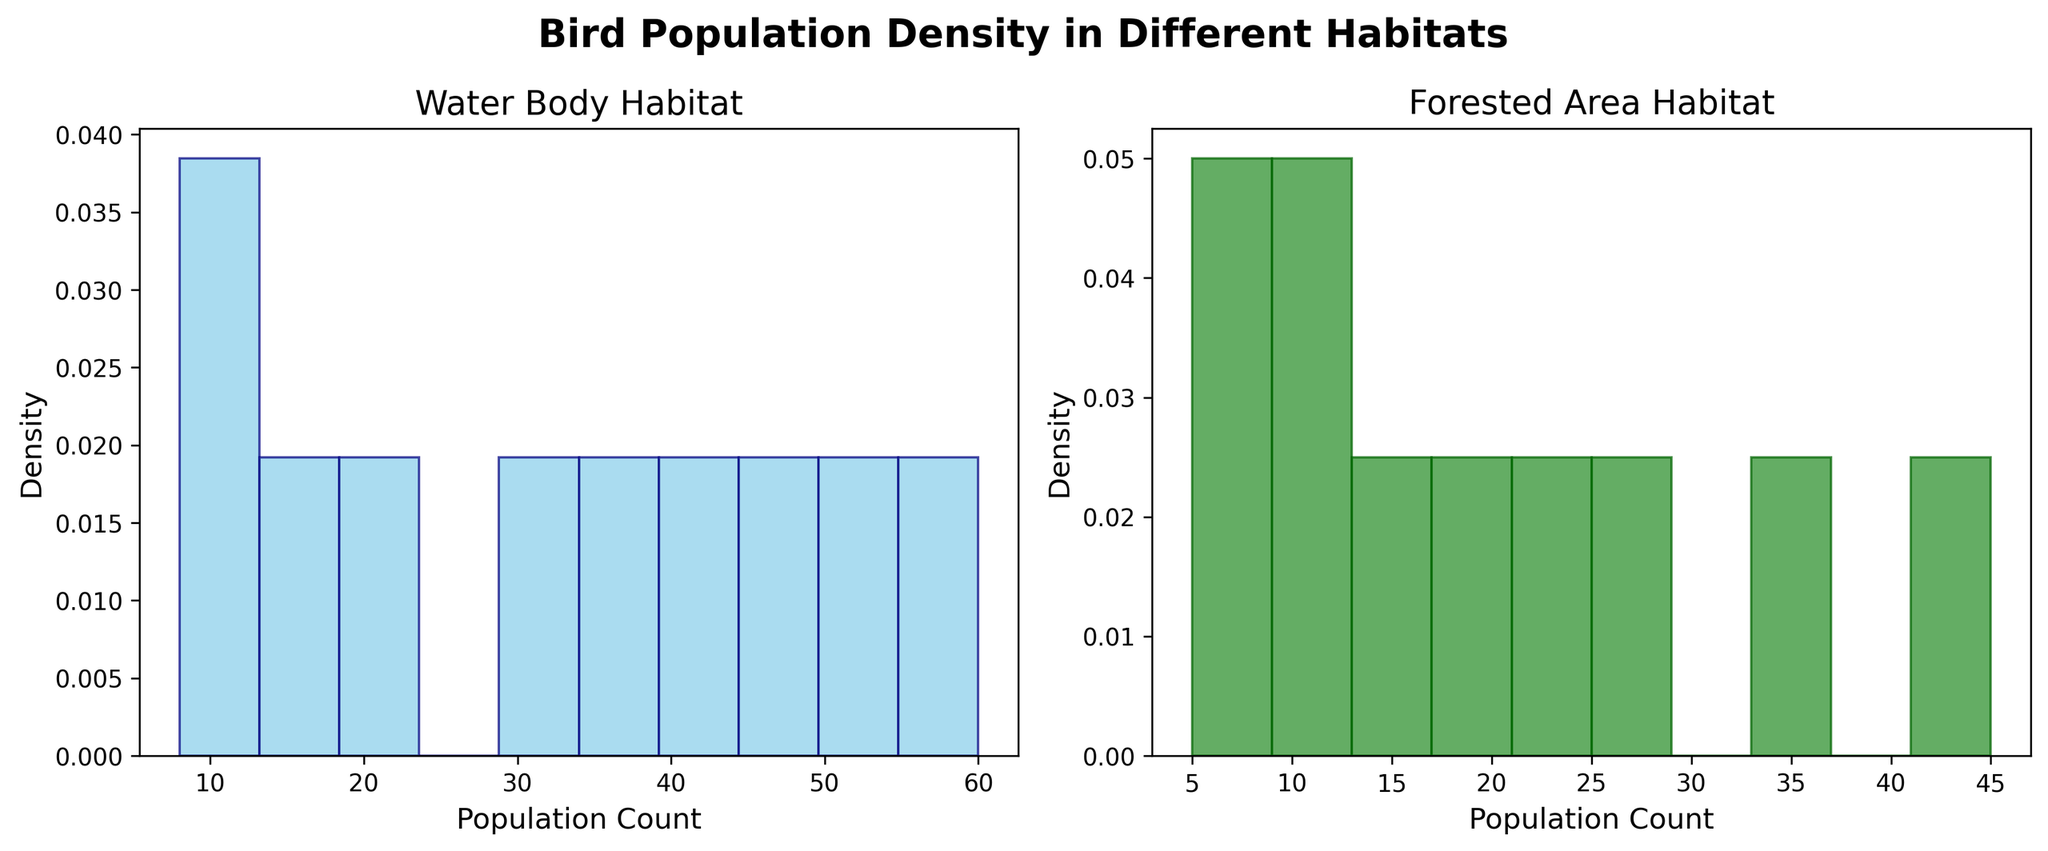what's the title of the figure? The title can be found at the top of the figure, which provides an overview of the plot.
Answer: Bird Population Density in Different Habitats What colors are used to represent the water body and forested area data? The colors differentiate the data for each habitat type to make the plot easier to read. The water body data is represented in sky blue and the forested area data in forest green.
Answer: Sky blue and forest green Which habitat type displays a higher peak density? By observing the peaks of both histograms, the water body habitat shows a higher peak compared to the forested area habitat. This can be seen by comparing the height of the highest bars in each histogram.
Answer: Water Body How many bins are used in each histogram? Both histograms are divided into 10 bins (10 bars), which is mentioned in the plot's coding parameters and observed visually by counting the bars.
Answer: 10 Which habitat type has the highest population count for a single species shown in the plot? By examining the ranges for the population count in each histogram, you can observe that the water body data has a higher maximum bin count compared to the forested area data.
Answer: Water Body What's the range of population counts for birds in water body habitats? The labels and bars on the x-axis of the water body histogram provide the necessary information. The range can be determined by observing the minimum and maximum population counts shown in the histogram, which are approximately between 5 and 60.
Answer: 5 to 60 Are the individual density curves overlapping in the figure? By visually inspecting the histograms, you can see that the density curves for water body and forested area habitats are plotted separately and are not overlapping.
Answer: No Is there a bird species population in forested areas that surpasses the highest peak density in water body habitats? By comparing the highest peak densities of both histograms, you need to find if any bar in the forested area histogram is taller than the highest bar in the water body histogram, which is not the case here.
Answer: No What are the x-axis labels for both subplots? Each subplot has its own x-axis which is labeled according to the habitat type. Both are labeled with 'Population Count' as indicated in the plot description.
Answer: Population Count Which histogram has a more spread-out population count distribution? By examining the spread of bars across both histograms, the forested area histogram is more spread out compared to the water body histogram, indicating a wider range of population counts.
Answer: Forested Area 